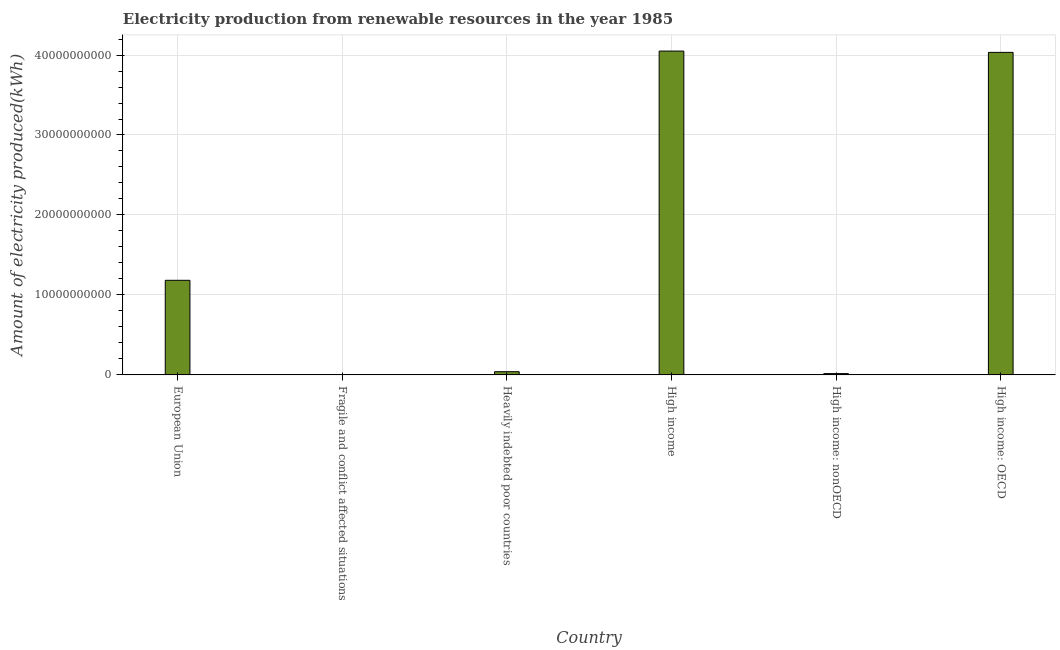Does the graph contain any zero values?
Make the answer very short. No. What is the title of the graph?
Keep it short and to the point. Electricity production from renewable resources in the year 1985. What is the label or title of the X-axis?
Keep it short and to the point. Country. What is the label or title of the Y-axis?
Provide a succinct answer. Amount of electricity produced(kWh). What is the amount of electricity produced in High income: nonOECD?
Your answer should be very brief. 1.64e+08. Across all countries, what is the maximum amount of electricity produced?
Offer a terse response. 4.05e+1. Across all countries, what is the minimum amount of electricity produced?
Provide a short and direct response. 1.50e+07. In which country was the amount of electricity produced minimum?
Provide a short and direct response. Fragile and conflict affected situations. What is the sum of the amount of electricity produced?
Ensure brevity in your answer.  9.32e+1. What is the difference between the amount of electricity produced in High income: OECD and High income: nonOECD?
Your answer should be compact. 4.02e+1. What is the average amount of electricity produced per country?
Your answer should be very brief. 1.55e+1. What is the median amount of electricity produced?
Your response must be concise. 6.12e+09. What is the ratio of the amount of electricity produced in High income: OECD to that in High income: nonOECD?
Offer a terse response. 245.92. What is the difference between the highest and the second highest amount of electricity produced?
Provide a succinct answer. 1.64e+08. What is the difference between the highest and the lowest amount of electricity produced?
Keep it short and to the point. 4.05e+1. In how many countries, is the amount of electricity produced greater than the average amount of electricity produced taken over all countries?
Make the answer very short. 2. How many bars are there?
Provide a short and direct response. 6. What is the difference between two consecutive major ticks on the Y-axis?
Offer a very short reply. 1.00e+1. What is the Amount of electricity produced(kWh) of European Union?
Provide a short and direct response. 1.18e+1. What is the Amount of electricity produced(kWh) of Fragile and conflict affected situations?
Your answer should be very brief. 1.50e+07. What is the Amount of electricity produced(kWh) of Heavily indebted poor countries?
Make the answer very short. 4.01e+08. What is the Amount of electricity produced(kWh) in High income?
Provide a succinct answer. 4.05e+1. What is the Amount of electricity produced(kWh) in High income: nonOECD?
Ensure brevity in your answer.  1.64e+08. What is the Amount of electricity produced(kWh) of High income: OECD?
Give a very brief answer. 4.03e+1. What is the difference between the Amount of electricity produced(kWh) in European Union and Fragile and conflict affected situations?
Keep it short and to the point. 1.18e+1. What is the difference between the Amount of electricity produced(kWh) in European Union and Heavily indebted poor countries?
Provide a succinct answer. 1.14e+1. What is the difference between the Amount of electricity produced(kWh) in European Union and High income?
Your answer should be very brief. -2.87e+1. What is the difference between the Amount of electricity produced(kWh) in European Union and High income: nonOECD?
Keep it short and to the point. 1.17e+1. What is the difference between the Amount of electricity produced(kWh) in European Union and High income: OECD?
Ensure brevity in your answer.  -2.85e+1. What is the difference between the Amount of electricity produced(kWh) in Fragile and conflict affected situations and Heavily indebted poor countries?
Make the answer very short. -3.86e+08. What is the difference between the Amount of electricity produced(kWh) in Fragile and conflict affected situations and High income?
Provide a short and direct response. -4.05e+1. What is the difference between the Amount of electricity produced(kWh) in Fragile and conflict affected situations and High income: nonOECD?
Ensure brevity in your answer.  -1.49e+08. What is the difference between the Amount of electricity produced(kWh) in Fragile and conflict affected situations and High income: OECD?
Make the answer very short. -4.03e+1. What is the difference between the Amount of electricity produced(kWh) in Heavily indebted poor countries and High income?
Offer a very short reply. -4.01e+1. What is the difference between the Amount of electricity produced(kWh) in Heavily indebted poor countries and High income: nonOECD?
Keep it short and to the point. 2.37e+08. What is the difference between the Amount of electricity produced(kWh) in Heavily indebted poor countries and High income: OECD?
Keep it short and to the point. -3.99e+1. What is the difference between the Amount of electricity produced(kWh) in High income and High income: nonOECD?
Offer a terse response. 4.03e+1. What is the difference between the Amount of electricity produced(kWh) in High income and High income: OECD?
Your response must be concise. 1.64e+08. What is the difference between the Amount of electricity produced(kWh) in High income: nonOECD and High income: OECD?
Offer a very short reply. -4.02e+1. What is the ratio of the Amount of electricity produced(kWh) in European Union to that in Fragile and conflict affected situations?
Give a very brief answer. 788.67. What is the ratio of the Amount of electricity produced(kWh) in European Union to that in Heavily indebted poor countries?
Ensure brevity in your answer.  29.5. What is the ratio of the Amount of electricity produced(kWh) in European Union to that in High income?
Provide a short and direct response. 0.29. What is the ratio of the Amount of electricity produced(kWh) in European Union to that in High income: nonOECD?
Your answer should be very brief. 72.13. What is the ratio of the Amount of electricity produced(kWh) in European Union to that in High income: OECD?
Offer a terse response. 0.29. What is the ratio of the Amount of electricity produced(kWh) in Fragile and conflict affected situations to that in Heavily indebted poor countries?
Provide a short and direct response. 0.04. What is the ratio of the Amount of electricity produced(kWh) in Fragile and conflict affected situations to that in High income: nonOECD?
Make the answer very short. 0.09. What is the ratio of the Amount of electricity produced(kWh) in Fragile and conflict affected situations to that in High income: OECD?
Offer a very short reply. 0. What is the ratio of the Amount of electricity produced(kWh) in Heavily indebted poor countries to that in High income: nonOECD?
Offer a very short reply. 2.44. What is the ratio of the Amount of electricity produced(kWh) in Heavily indebted poor countries to that in High income: OECD?
Provide a succinct answer. 0.01. What is the ratio of the Amount of electricity produced(kWh) in High income to that in High income: nonOECD?
Keep it short and to the point. 246.92. What is the ratio of the Amount of electricity produced(kWh) in High income: nonOECD to that in High income: OECD?
Make the answer very short. 0. 